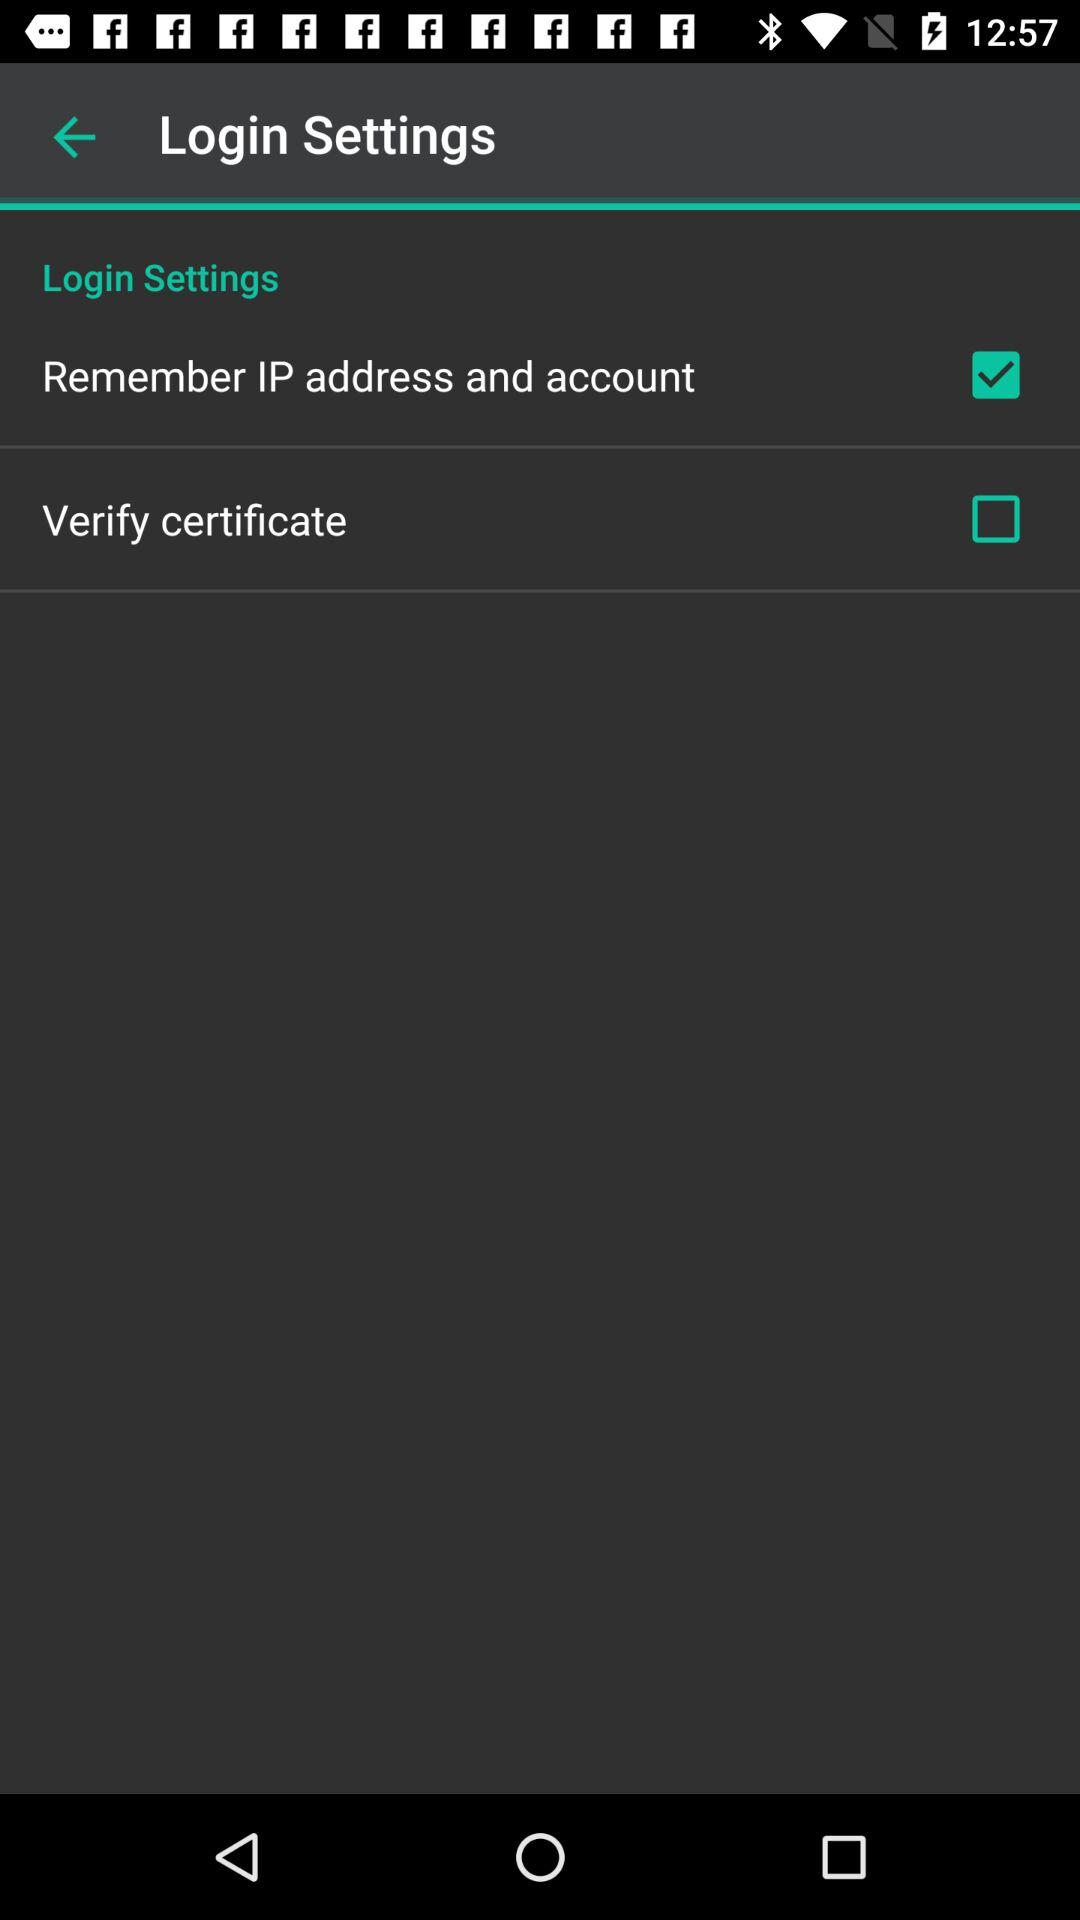How many check boxes are there in this login settings page?
Answer the question using a single word or phrase. 2 